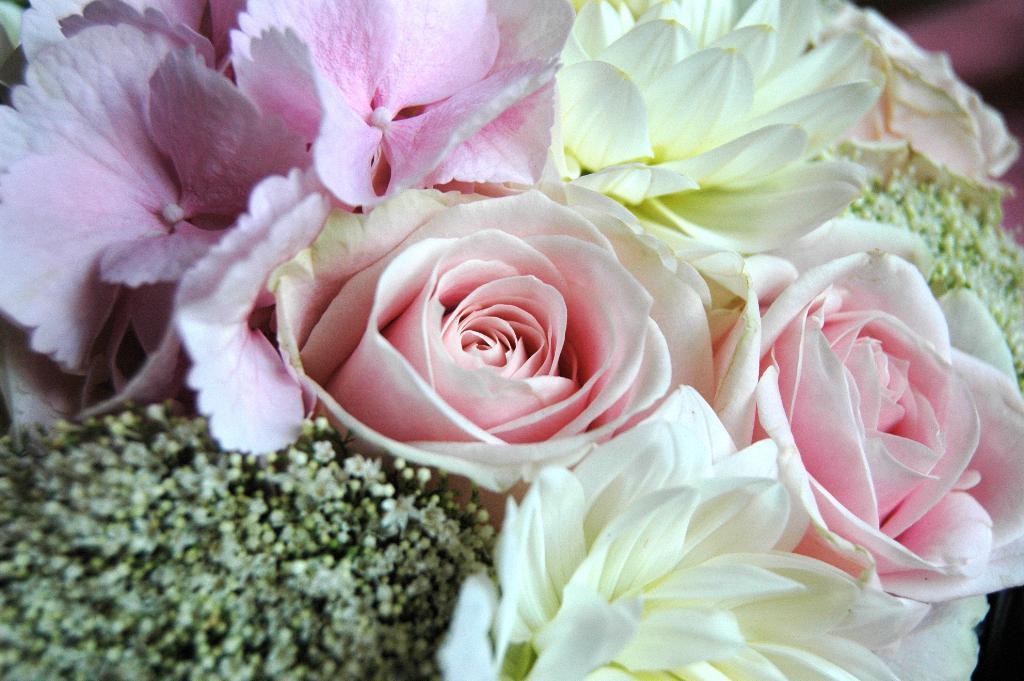Can you describe this image briefly? In this picture we can see different colors of flowers and in the background it is blurry. 